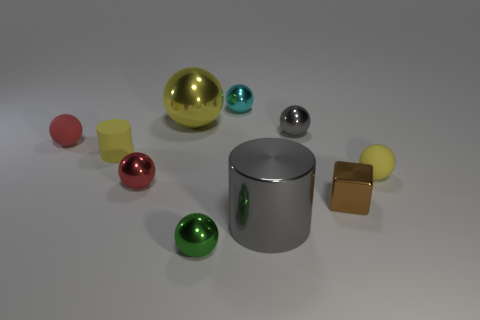Subtract all small red metal balls. How many balls are left? 6 Subtract all red balls. How many balls are left? 5 Subtract all purple spheres. Subtract all purple cylinders. How many spheres are left? 7 Subtract all spheres. How many objects are left? 3 Add 8 brown blocks. How many brown blocks exist? 9 Subtract 1 gray spheres. How many objects are left? 9 Subtract all small red objects. Subtract all large gray cylinders. How many objects are left? 7 Add 6 brown objects. How many brown objects are left? 7 